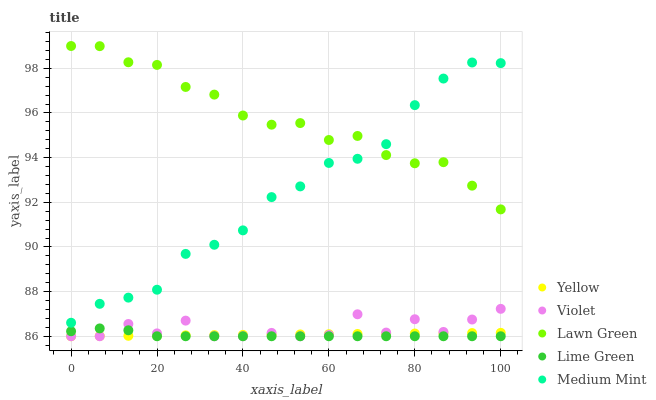Does Lime Green have the minimum area under the curve?
Answer yes or no. Yes. Does Lawn Green have the maximum area under the curve?
Answer yes or no. Yes. Does Lawn Green have the minimum area under the curve?
Answer yes or no. No. Does Lime Green have the maximum area under the curve?
Answer yes or no. No. Is Yellow the smoothest?
Answer yes or no. Yes. Is Violet the roughest?
Answer yes or no. Yes. Is Lawn Green the smoothest?
Answer yes or no. No. Is Lawn Green the roughest?
Answer yes or no. No. Does Lime Green have the lowest value?
Answer yes or no. Yes. Does Lawn Green have the lowest value?
Answer yes or no. No. Does Lawn Green have the highest value?
Answer yes or no. Yes. Does Lime Green have the highest value?
Answer yes or no. No. Is Yellow less than Medium Mint?
Answer yes or no. Yes. Is Medium Mint greater than Lime Green?
Answer yes or no. Yes. Does Lime Green intersect Yellow?
Answer yes or no. Yes. Is Lime Green less than Yellow?
Answer yes or no. No. Is Lime Green greater than Yellow?
Answer yes or no. No. Does Yellow intersect Medium Mint?
Answer yes or no. No. 